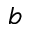<formula> <loc_0><loc_0><loc_500><loc_500>b</formula> 